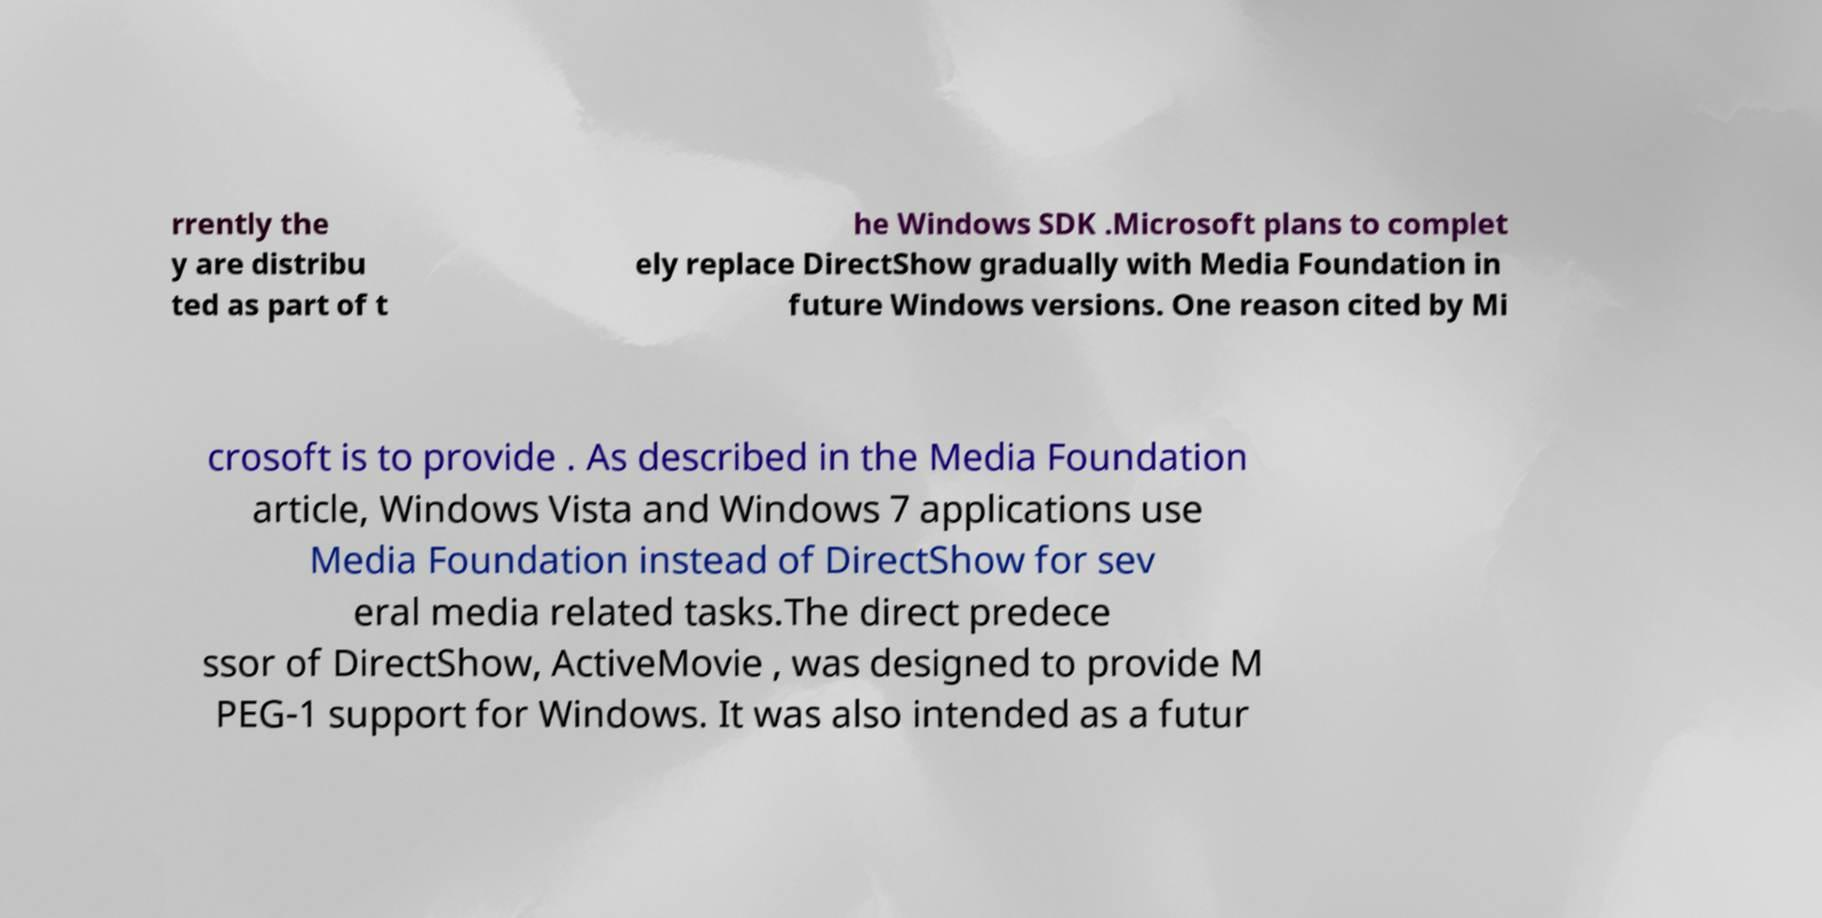There's text embedded in this image that I need extracted. Can you transcribe it verbatim? rrently the y are distribu ted as part of t he Windows SDK .Microsoft plans to complet ely replace DirectShow gradually with Media Foundation in future Windows versions. One reason cited by Mi crosoft is to provide . As described in the Media Foundation article, Windows Vista and Windows 7 applications use Media Foundation instead of DirectShow for sev eral media related tasks.The direct predece ssor of DirectShow, ActiveMovie , was designed to provide M PEG-1 support for Windows. It was also intended as a futur 